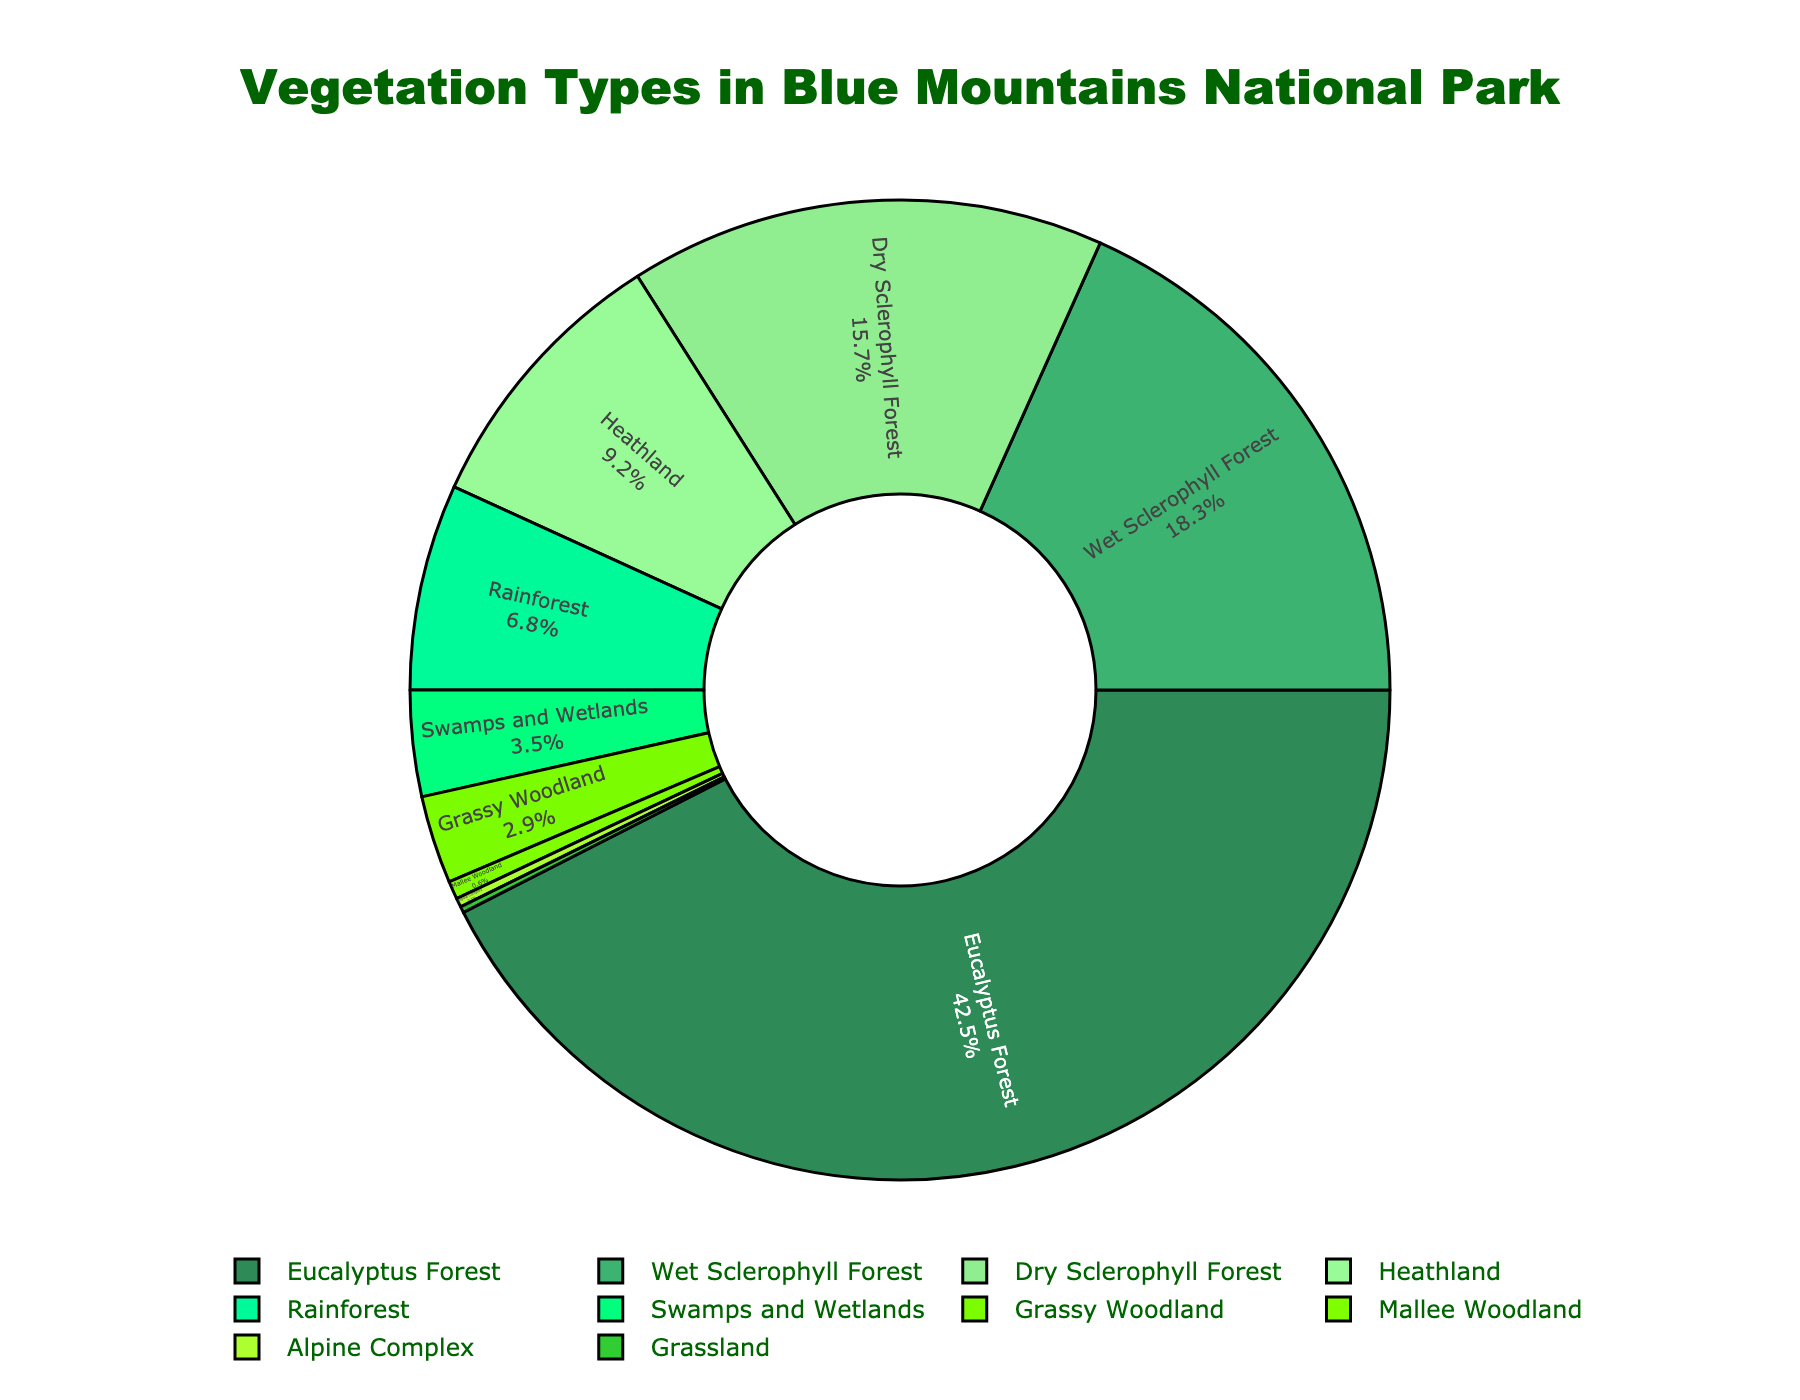What is the most abundant vegetation type in the Blue Mountains National Park? The chart shows that the vegetation type with the highest percentage is Eucalyptus Forest.
Answer: Eucalyptus Forest How much greater is the percentage of Wet Sclerophyll Forest compared to Grassland? Wet Sclerophyll Forest has 18.3%, and Grassland has 0.2%. The difference is calculated as 18.3% - 0.2% = 18.1%.
Answer: 18.1% What two vegetation types together make up just over 33% of the total vegetation composition? Wet Sclerophyll Forest has 18.3% and Dry Sclerophyll Forest has 15.7%, together making up 18.3% + 15.7% = 34%.
Answer: Wet Sclerophyll Forest and Dry Sclerophyll Forest Which vegetation type has the smallest representation in the Blue Mountains National Park, and what is its percentage? By examining the pie chart, the smallest slice is for Grassland, which has a percentage of 0.2%.
Answer: Grassland, 0.2% How does the area covered by swamps and wetlands compare with that covered by grassy woodland? Swamps and Wetlands cover 3.5%, while Grassy Woodland covers 2.9%. Comparing these, Swamps and Wetlands cover more area.
Answer: Swamps and Wetlands What is the total percentage for all vegetation types that cover less than 5% individually? Adding percentages of Rainforest (6.8%), Swamps and Wetlands (3.5%), Grassy Woodland (2.9%), Mallee Woodland (0.6%), Alpine Complex (0.3%), and Grassland (0.2%): 6.8% + 3.5% + 2.9% + 0.6% + 0.3% + 0.2% = 14.3%.
Answer: 14.3% What is the combined total percentage of both Sclerophyll Forest types (Wet and Dry)? Wet Sclerophyll Forest is 18.3% and Dry Sclerophyll Forest is 15.7%. Combining them: 18.3% + 15.7% = 34%.
Answer: 34% Among Heathland, Rainforest, and Swamps and Wetlands, which has the second highest percentage? Percentages are Heathland (9.2%), Rainforest (6.8%), and Swamps and Wetlands (3.5%). The second highest percentage is Rainforest.
Answer: Rainforest Is the total percentage of Eucalyptus Forest more than the combined total of the next two largest vegetation types? Eucalyptus Forest is 42.5%. Wet Sclerophyll Forest and Dry Sclerophyll Forest together are 18.3% + 15.7% = 34%. 42.5% > 34%, so yes.
Answer: Yes What percentage of vegetation is neither Eucalyptus Forest, Wet Sclerophyll Forest, nor Dry Sclerophyll Forest? Summing Eucalyptus Forest, Wet Sclerophyll Forest, and Dry Sclerophyll Forest: 42.5% + 18.3% + 15.7% = 76.5%. Subtracting this from 100%: 100% - 76.5% = 23.5%.
Answer: 23.5% 